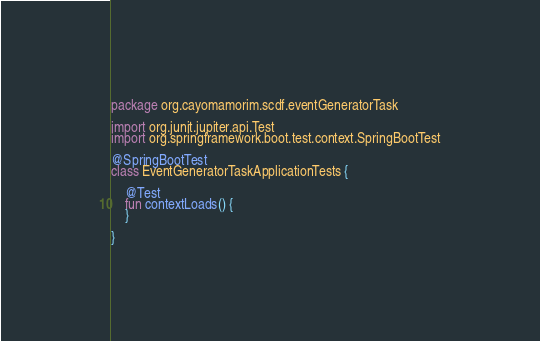<code> <loc_0><loc_0><loc_500><loc_500><_Kotlin_>package org.cayomamorim.scdf.eventGeneratorTask

import org.junit.jupiter.api.Test
import org.springframework.boot.test.context.SpringBootTest

@SpringBootTest
class EventGeneratorTaskApplicationTests {

	@Test
	fun contextLoads() {
	}

}
</code> 